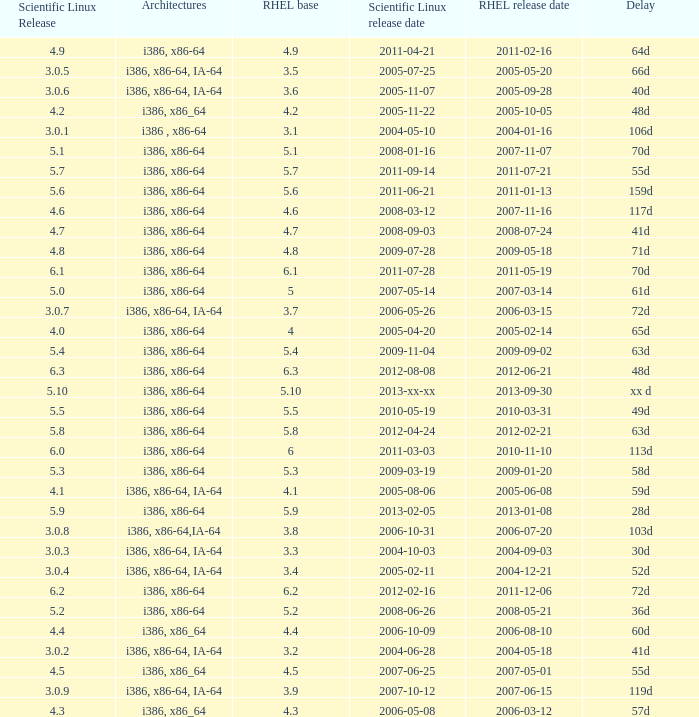Name the delay when scientific linux release is 5.10 Xx d. 